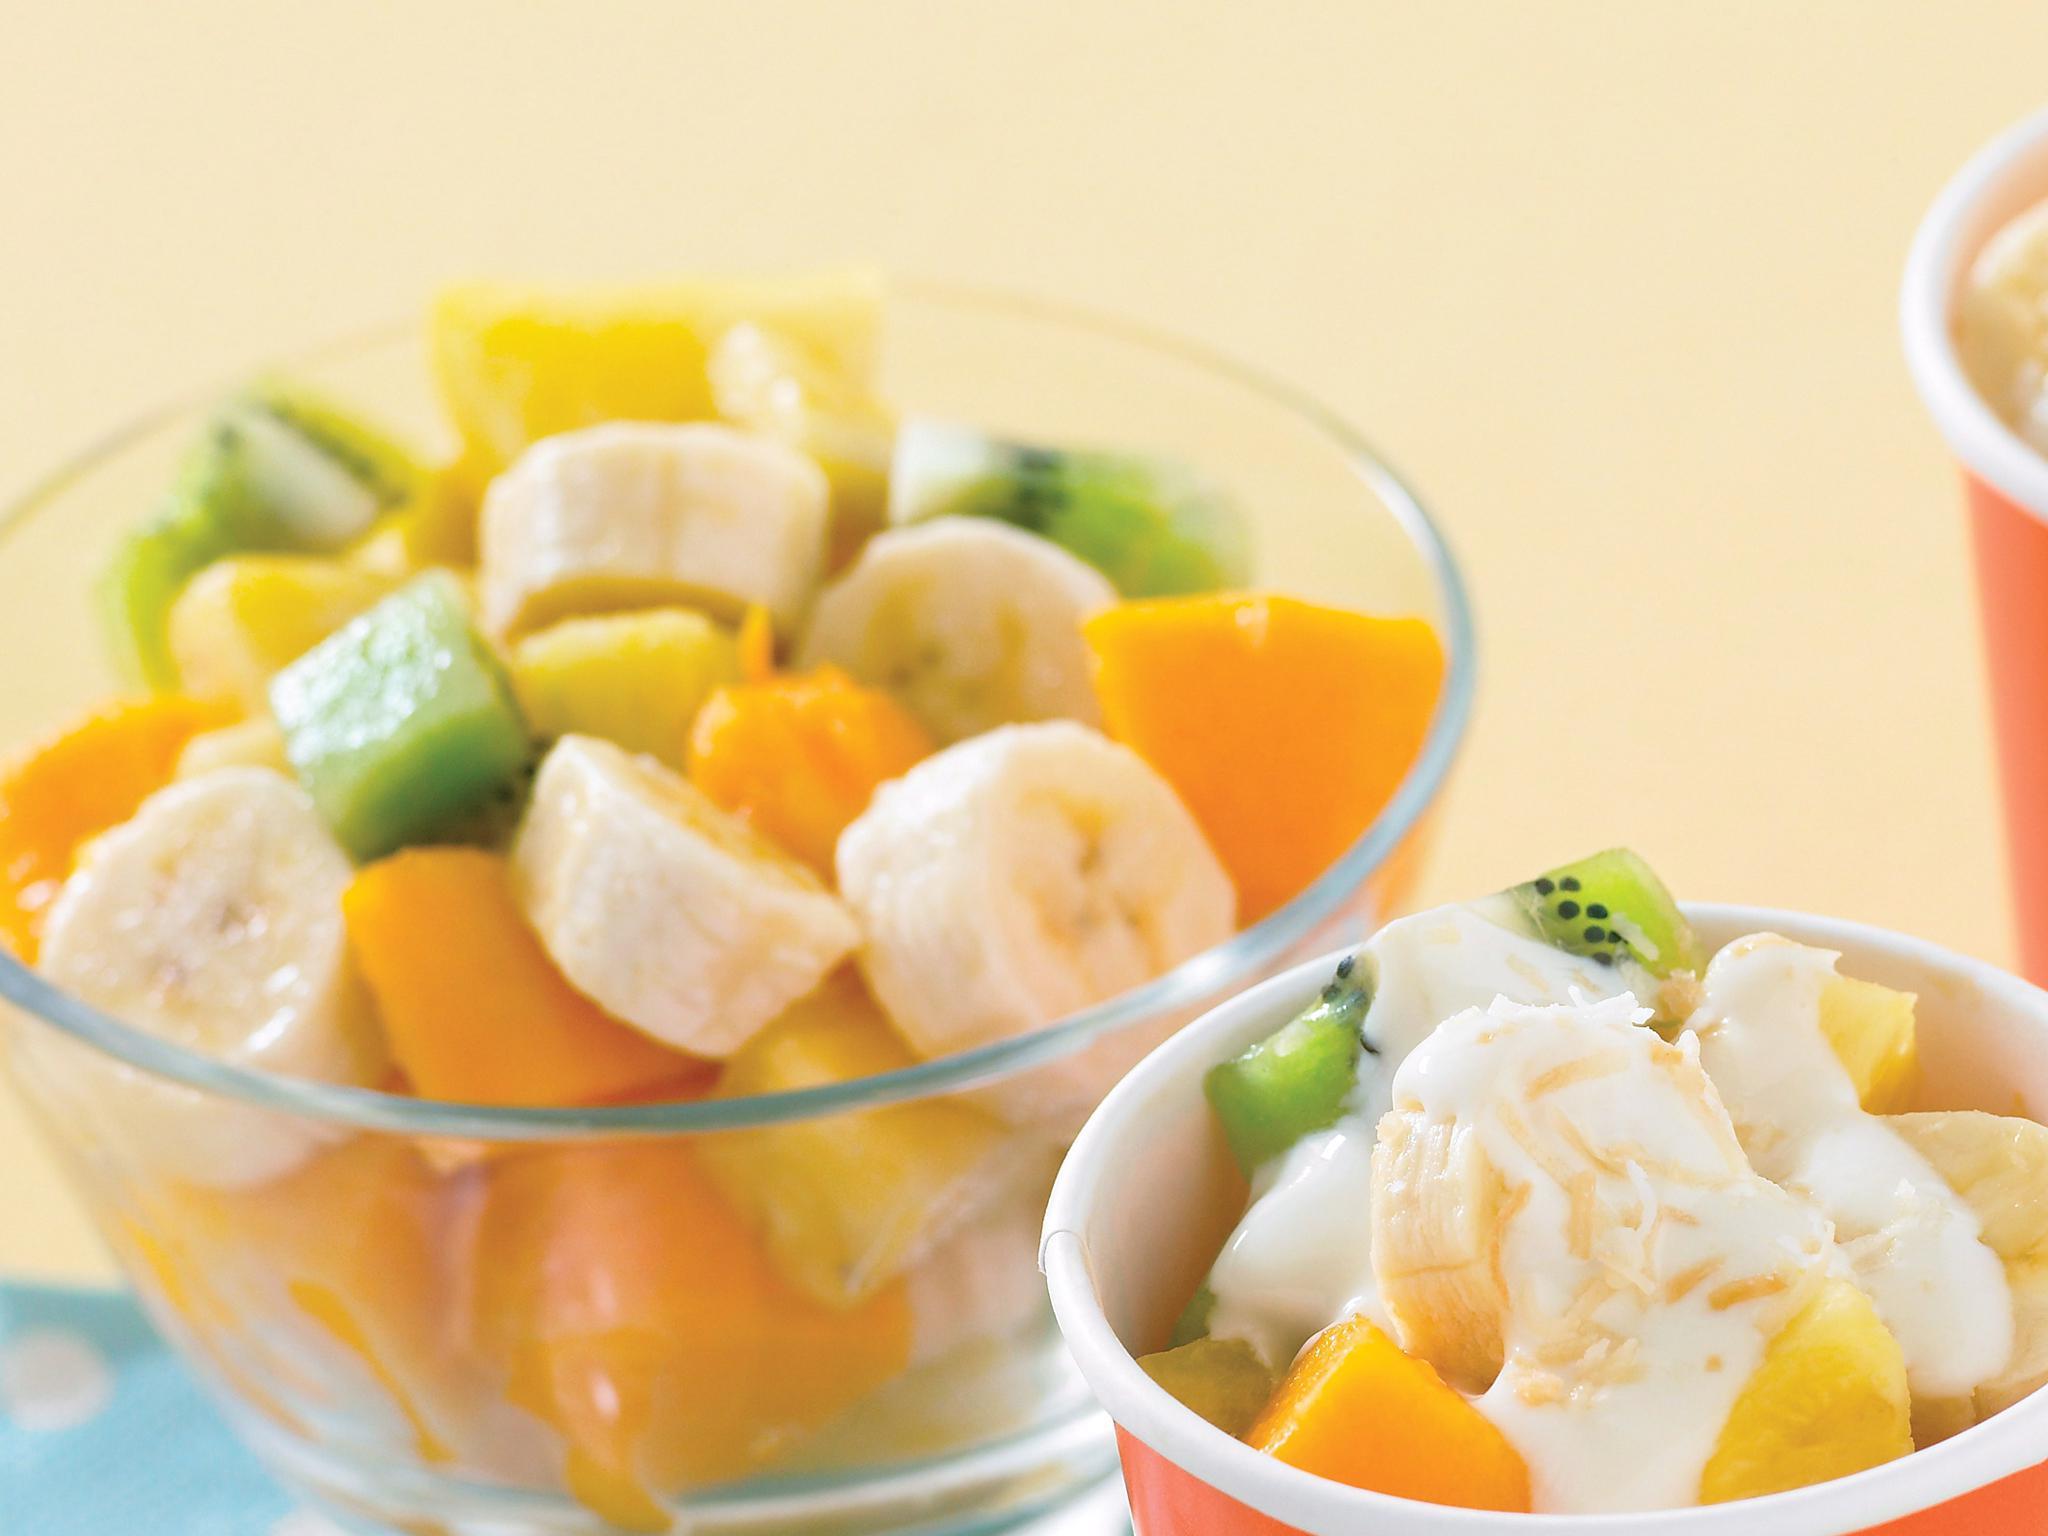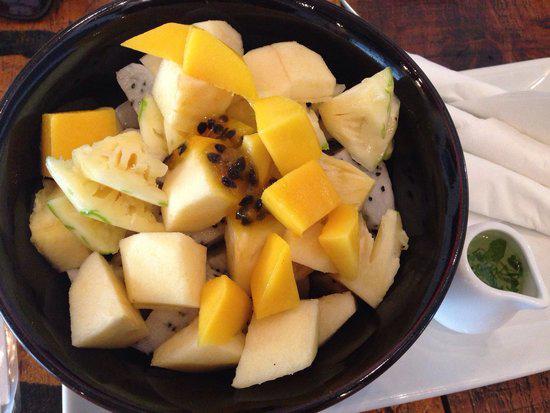The first image is the image on the left, the second image is the image on the right. Evaluate the accuracy of this statement regarding the images: "The left image shows mixed fruit pieces in a white bowl, and the right image shows sliced bananas in an octagon-shaped black bowl.". Is it true? Answer yes or no. No. The first image is the image on the left, the second image is the image on the right. Assess this claim about the two images: "there is a white bowl with strawberries bananas and other varying fruits". Correct or not? Answer yes or no. No. 